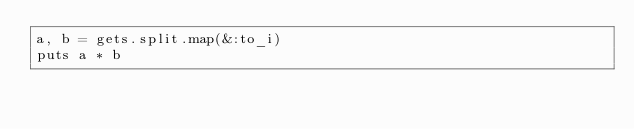Convert code to text. <code><loc_0><loc_0><loc_500><loc_500><_Ruby_>a, b = gets.split.map(&:to_i)
puts a * b
</code> 